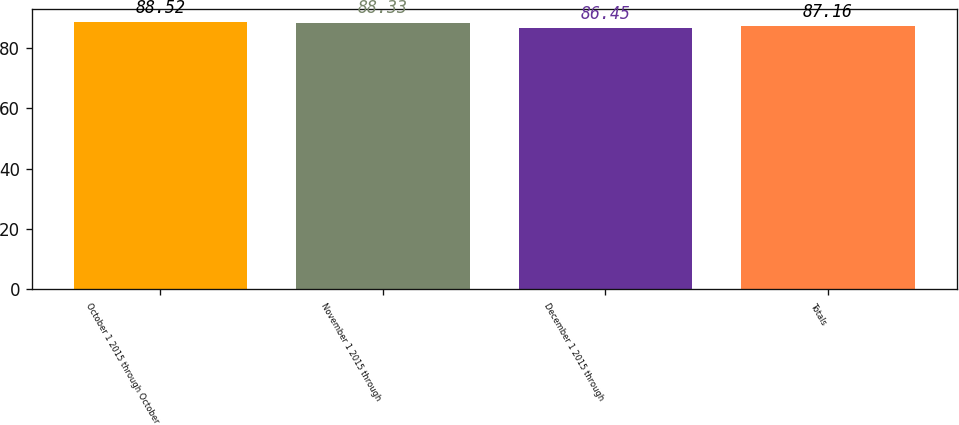<chart> <loc_0><loc_0><loc_500><loc_500><bar_chart><fcel>October 1 2015 through October<fcel>November 1 2015 through<fcel>December 1 2015 through<fcel>Totals<nl><fcel>88.52<fcel>88.33<fcel>86.45<fcel>87.16<nl></chart> 